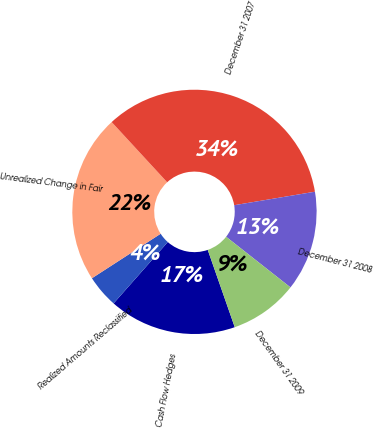<chart> <loc_0><loc_0><loc_500><loc_500><pie_chart><fcel>Cash Flow Hedges<fcel>Realized Amounts Reclassified<fcel>Unrealized Change in Fair<fcel>December 31 2007<fcel>December 31 2008<fcel>December 31 2009<nl><fcel>16.87%<fcel>4.34%<fcel>22.29%<fcel>34.22%<fcel>13.25%<fcel>9.04%<nl></chart> 